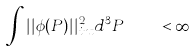Convert formula to latex. <formula><loc_0><loc_0><loc_500><loc_500>\int \nolimits | | \phi ( { P } ) | | _ { i n t } ^ { 2 } d ^ { 3 } { P } \quad < \infty</formula> 